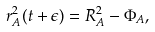Convert formula to latex. <formula><loc_0><loc_0><loc_500><loc_500>r ^ { 2 } _ { A } ( t + \epsilon ) = R ^ { 2 } _ { A } - \Phi _ { A } ,</formula> 